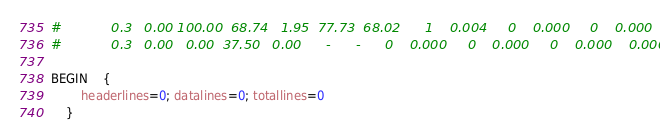<code> <loc_0><loc_0><loc_500><loc_500><_Awk_>#            0.3   0.00 100.00  68.74   1.95  77.73  68.02      1    0.004     0    0.000     0    0.000    0.004
#            0.3   0.00   0.00  37.50   0.00      -      -      0    0.000     0    0.000     0    0.000    0.000

BEGIN	{
	    headerlines=0; datalines=0; totallines=0
	}
</code> 